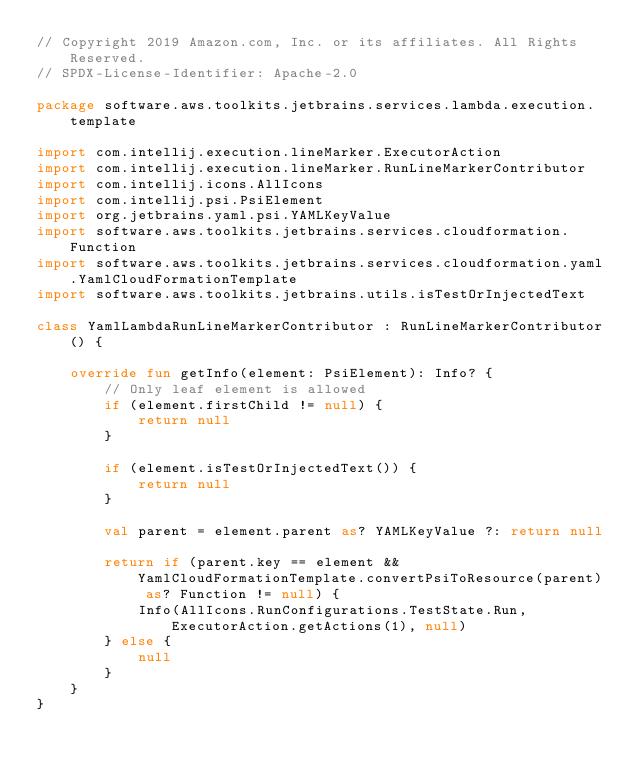Convert code to text. <code><loc_0><loc_0><loc_500><loc_500><_Kotlin_>// Copyright 2019 Amazon.com, Inc. or its affiliates. All Rights Reserved.
// SPDX-License-Identifier: Apache-2.0

package software.aws.toolkits.jetbrains.services.lambda.execution.template

import com.intellij.execution.lineMarker.ExecutorAction
import com.intellij.execution.lineMarker.RunLineMarkerContributor
import com.intellij.icons.AllIcons
import com.intellij.psi.PsiElement
import org.jetbrains.yaml.psi.YAMLKeyValue
import software.aws.toolkits.jetbrains.services.cloudformation.Function
import software.aws.toolkits.jetbrains.services.cloudformation.yaml.YamlCloudFormationTemplate
import software.aws.toolkits.jetbrains.utils.isTestOrInjectedText

class YamlLambdaRunLineMarkerContributor : RunLineMarkerContributor() {

    override fun getInfo(element: PsiElement): Info? {
        // Only leaf element is allowed
        if (element.firstChild != null) {
            return null
        }

        if (element.isTestOrInjectedText()) {
            return null
        }

        val parent = element.parent as? YAMLKeyValue ?: return null

        return if (parent.key == element && YamlCloudFormationTemplate.convertPsiToResource(parent) as? Function != null) {
            Info(AllIcons.RunConfigurations.TestState.Run, ExecutorAction.getActions(1), null)
        } else {
            null
        }
    }
}
</code> 